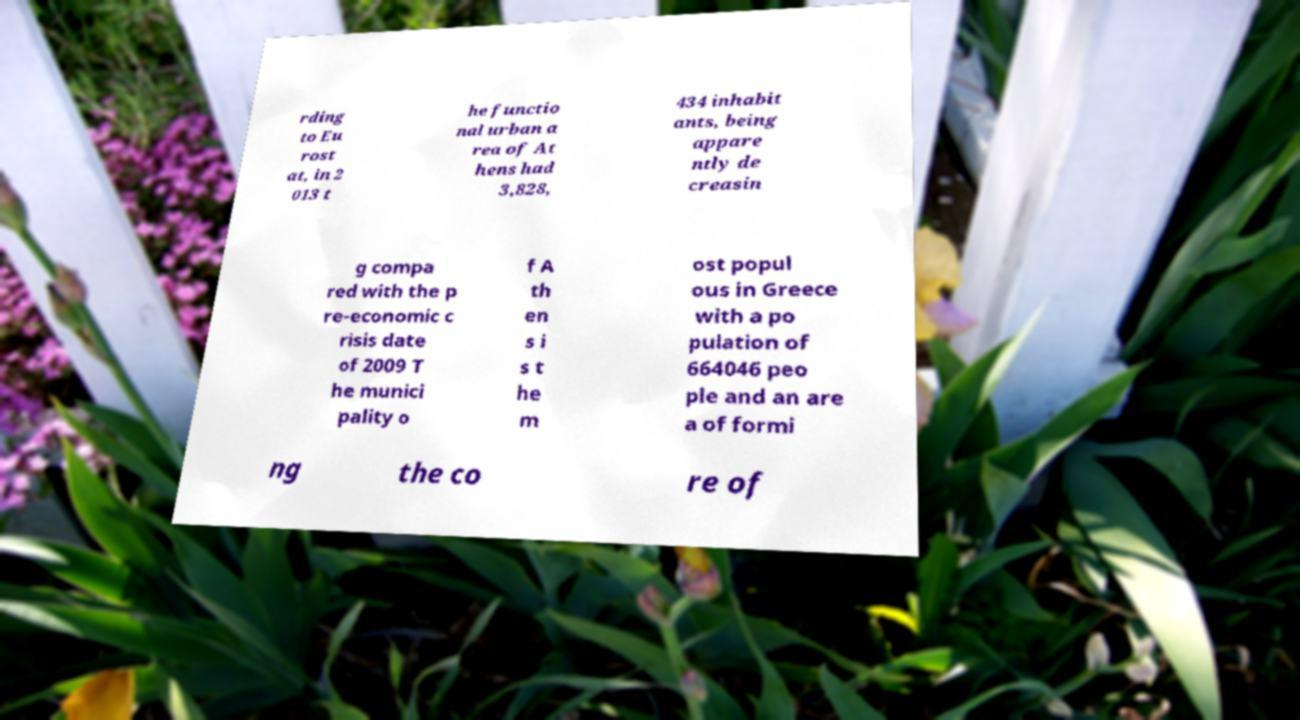What messages or text are displayed in this image? I need them in a readable, typed format. rding to Eu rost at, in 2 013 t he functio nal urban a rea of At hens had 3,828, 434 inhabit ants, being appare ntly de creasin g compa red with the p re-economic c risis date of 2009 T he munici pality o f A th en s i s t he m ost popul ous in Greece with a po pulation of 664046 peo ple and an are a of formi ng the co re of 